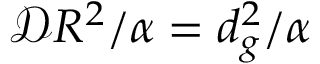Convert formula to latex. <formula><loc_0><loc_0><loc_500><loc_500>\mathcal { D } R ^ { 2 } / \alpha = d _ { g } ^ { 2 } / \alpha</formula> 